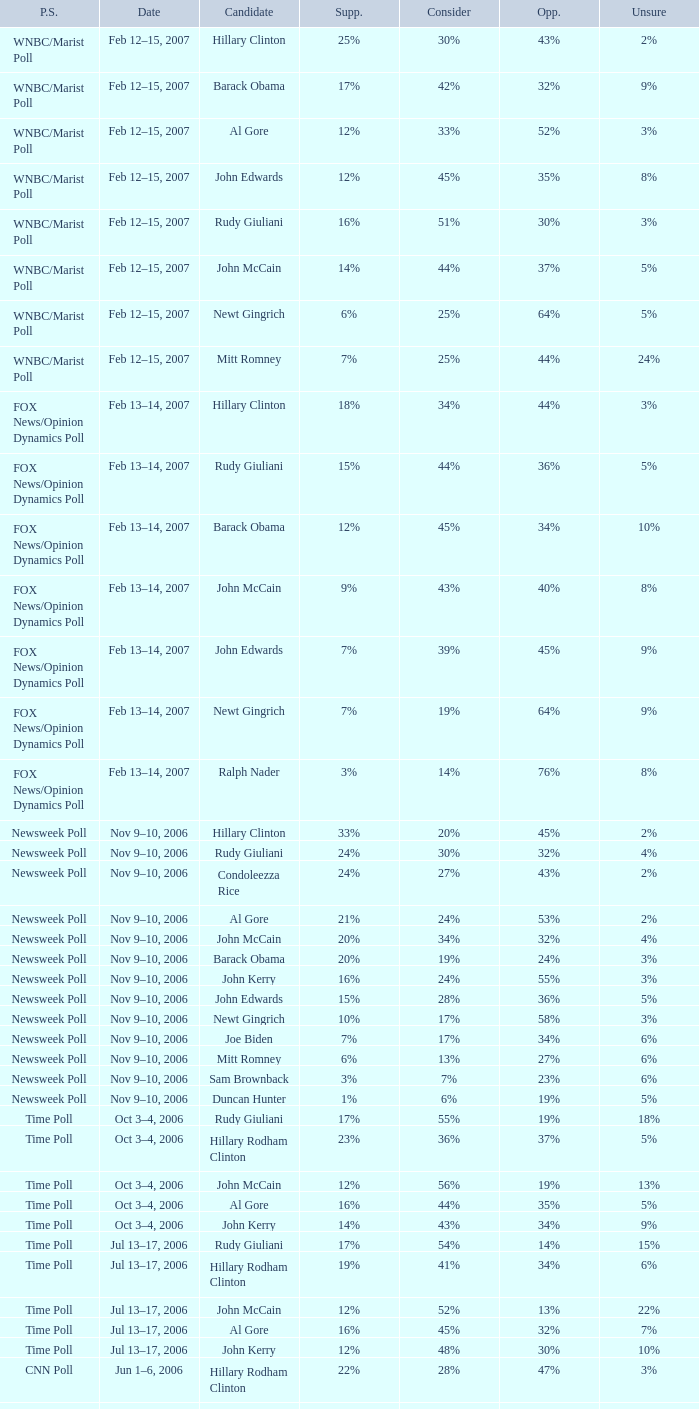What percentage of people were opposed to the candidate based on the WNBC/Marist poll that showed 8% of people were unsure? 35%. 